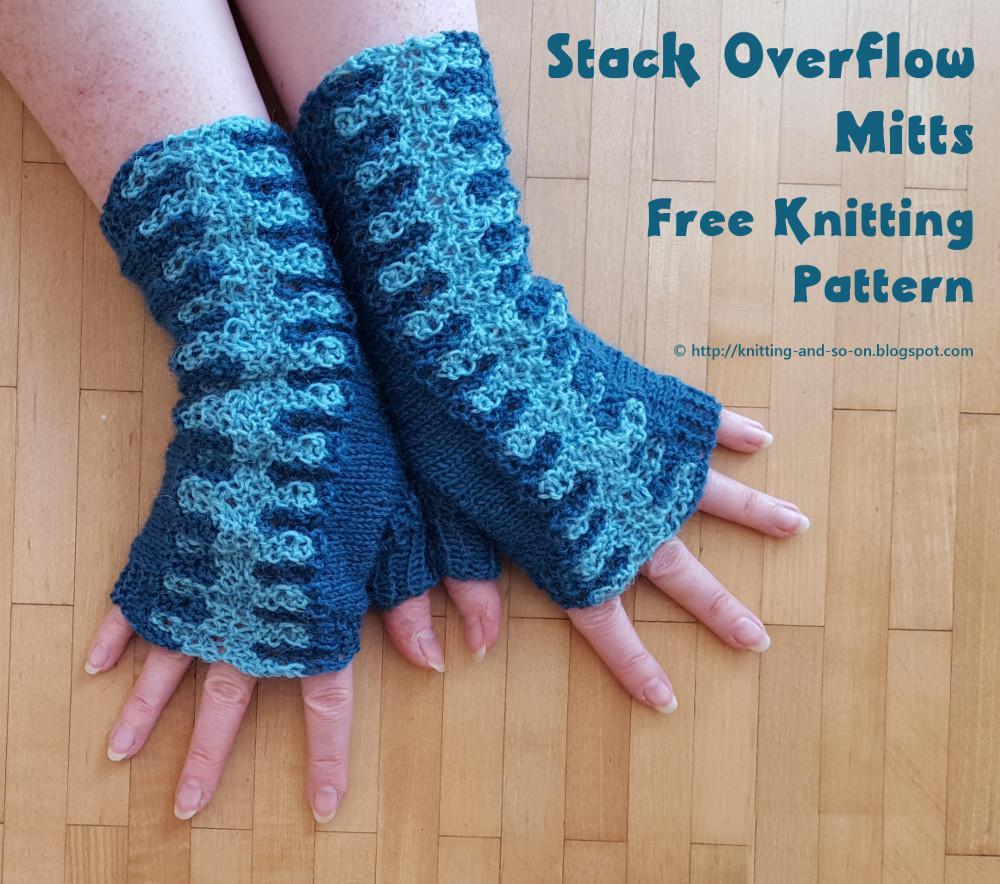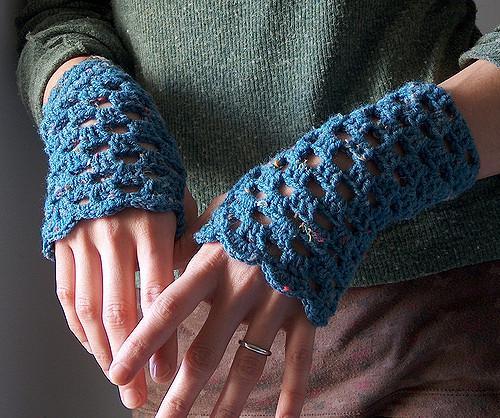The first image is the image on the left, the second image is the image on the right. Analyze the images presented: Is the assertion "A pair of gloves is being worn on a set of hands in the image on the left." valid? Answer yes or no. Yes. The first image is the image on the left, the second image is the image on the right. Evaluate the accuracy of this statement regarding the images: "The left image contains a human wearing blue gloves that have the finger tips cut off.". Is it true? Answer yes or no. Yes. 